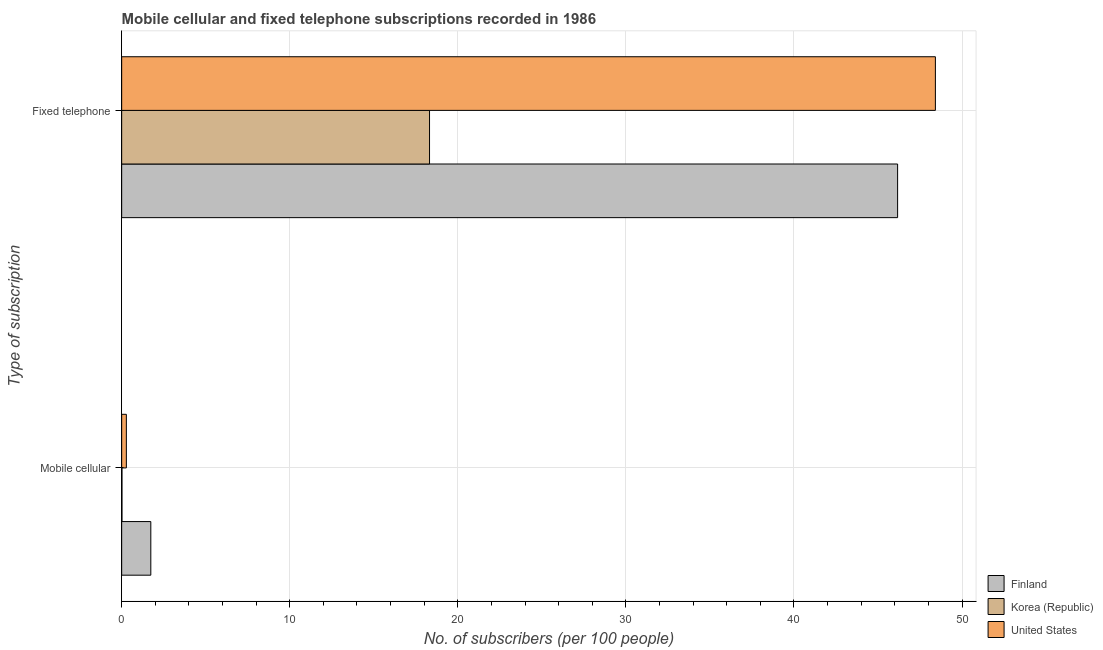How many different coloured bars are there?
Your response must be concise. 3. How many groups of bars are there?
Provide a short and direct response. 2. Are the number of bars per tick equal to the number of legend labels?
Offer a terse response. Yes. How many bars are there on the 1st tick from the top?
Give a very brief answer. 3. What is the label of the 2nd group of bars from the top?
Give a very brief answer. Mobile cellular. What is the number of mobile cellular subscribers in United States?
Your answer should be compact. 0.28. Across all countries, what is the maximum number of fixed telephone subscribers?
Make the answer very short. 48.41. Across all countries, what is the minimum number of fixed telephone subscribers?
Your answer should be compact. 18.32. In which country was the number of mobile cellular subscribers minimum?
Give a very brief answer. Korea (Republic). What is the total number of fixed telephone subscribers in the graph?
Your response must be concise. 112.9. What is the difference between the number of fixed telephone subscribers in Korea (Republic) and that in United States?
Ensure brevity in your answer.  -30.1. What is the difference between the number of fixed telephone subscribers in Korea (Republic) and the number of mobile cellular subscribers in Finland?
Make the answer very short. 16.58. What is the average number of fixed telephone subscribers per country?
Make the answer very short. 37.63. What is the difference between the number of mobile cellular subscribers and number of fixed telephone subscribers in Korea (Republic)?
Provide a short and direct response. -18.3. What is the ratio of the number of fixed telephone subscribers in United States to that in Korea (Republic)?
Your answer should be compact. 2.64. Is the number of mobile cellular subscribers in United States less than that in Finland?
Give a very brief answer. Yes. How many bars are there?
Offer a terse response. 6. Are all the bars in the graph horizontal?
Keep it short and to the point. Yes. How many countries are there in the graph?
Make the answer very short. 3. What is the difference between two consecutive major ticks on the X-axis?
Your answer should be very brief. 10. Are the values on the major ticks of X-axis written in scientific E-notation?
Your answer should be very brief. No. Does the graph contain grids?
Provide a succinct answer. Yes. How many legend labels are there?
Your answer should be very brief. 3. How are the legend labels stacked?
Offer a very short reply. Vertical. What is the title of the graph?
Offer a very short reply. Mobile cellular and fixed telephone subscriptions recorded in 1986. What is the label or title of the X-axis?
Provide a short and direct response. No. of subscribers (per 100 people). What is the label or title of the Y-axis?
Offer a terse response. Type of subscription. What is the No. of subscribers (per 100 people) in Finland in Mobile cellular?
Ensure brevity in your answer.  1.73. What is the No. of subscribers (per 100 people) in Korea (Republic) in Mobile cellular?
Your answer should be very brief. 0.02. What is the No. of subscribers (per 100 people) of United States in Mobile cellular?
Ensure brevity in your answer.  0.28. What is the No. of subscribers (per 100 people) in Finland in Fixed telephone?
Give a very brief answer. 46.17. What is the No. of subscribers (per 100 people) of Korea (Republic) in Fixed telephone?
Your answer should be compact. 18.32. What is the No. of subscribers (per 100 people) in United States in Fixed telephone?
Make the answer very short. 48.41. Across all Type of subscription, what is the maximum No. of subscribers (per 100 people) in Finland?
Your answer should be compact. 46.17. Across all Type of subscription, what is the maximum No. of subscribers (per 100 people) in Korea (Republic)?
Keep it short and to the point. 18.32. Across all Type of subscription, what is the maximum No. of subscribers (per 100 people) of United States?
Provide a short and direct response. 48.41. Across all Type of subscription, what is the minimum No. of subscribers (per 100 people) of Finland?
Provide a succinct answer. 1.73. Across all Type of subscription, what is the minimum No. of subscribers (per 100 people) of Korea (Republic)?
Offer a terse response. 0.02. Across all Type of subscription, what is the minimum No. of subscribers (per 100 people) of United States?
Your answer should be compact. 0.28. What is the total No. of subscribers (per 100 people) of Finland in the graph?
Provide a short and direct response. 47.9. What is the total No. of subscribers (per 100 people) of Korea (Republic) in the graph?
Ensure brevity in your answer.  18.33. What is the total No. of subscribers (per 100 people) in United States in the graph?
Offer a very short reply. 48.69. What is the difference between the No. of subscribers (per 100 people) in Finland in Mobile cellular and that in Fixed telephone?
Give a very brief answer. -44.43. What is the difference between the No. of subscribers (per 100 people) in Korea (Republic) in Mobile cellular and that in Fixed telephone?
Make the answer very short. -18.3. What is the difference between the No. of subscribers (per 100 people) of United States in Mobile cellular and that in Fixed telephone?
Make the answer very short. -48.13. What is the difference between the No. of subscribers (per 100 people) of Finland in Mobile cellular and the No. of subscribers (per 100 people) of Korea (Republic) in Fixed telephone?
Your answer should be compact. -16.58. What is the difference between the No. of subscribers (per 100 people) in Finland in Mobile cellular and the No. of subscribers (per 100 people) in United States in Fixed telephone?
Your answer should be very brief. -46.68. What is the difference between the No. of subscribers (per 100 people) in Korea (Republic) in Mobile cellular and the No. of subscribers (per 100 people) in United States in Fixed telephone?
Your answer should be very brief. -48.4. What is the average No. of subscribers (per 100 people) of Finland per Type of subscription?
Give a very brief answer. 23.95. What is the average No. of subscribers (per 100 people) in Korea (Republic) per Type of subscription?
Offer a very short reply. 9.17. What is the average No. of subscribers (per 100 people) in United States per Type of subscription?
Provide a short and direct response. 24.35. What is the difference between the No. of subscribers (per 100 people) in Finland and No. of subscribers (per 100 people) in Korea (Republic) in Mobile cellular?
Your response must be concise. 1.72. What is the difference between the No. of subscribers (per 100 people) in Finland and No. of subscribers (per 100 people) in United States in Mobile cellular?
Offer a terse response. 1.45. What is the difference between the No. of subscribers (per 100 people) in Korea (Republic) and No. of subscribers (per 100 people) in United States in Mobile cellular?
Provide a short and direct response. -0.26. What is the difference between the No. of subscribers (per 100 people) in Finland and No. of subscribers (per 100 people) in Korea (Republic) in Fixed telephone?
Offer a terse response. 27.85. What is the difference between the No. of subscribers (per 100 people) in Finland and No. of subscribers (per 100 people) in United States in Fixed telephone?
Your response must be concise. -2.25. What is the difference between the No. of subscribers (per 100 people) of Korea (Republic) and No. of subscribers (per 100 people) of United States in Fixed telephone?
Give a very brief answer. -30.1. What is the ratio of the No. of subscribers (per 100 people) in Finland in Mobile cellular to that in Fixed telephone?
Offer a terse response. 0.04. What is the ratio of the No. of subscribers (per 100 people) of Korea (Republic) in Mobile cellular to that in Fixed telephone?
Offer a terse response. 0. What is the ratio of the No. of subscribers (per 100 people) in United States in Mobile cellular to that in Fixed telephone?
Ensure brevity in your answer.  0.01. What is the difference between the highest and the second highest No. of subscribers (per 100 people) in Finland?
Ensure brevity in your answer.  44.43. What is the difference between the highest and the second highest No. of subscribers (per 100 people) of Korea (Republic)?
Provide a short and direct response. 18.3. What is the difference between the highest and the second highest No. of subscribers (per 100 people) in United States?
Make the answer very short. 48.13. What is the difference between the highest and the lowest No. of subscribers (per 100 people) in Finland?
Provide a short and direct response. 44.43. What is the difference between the highest and the lowest No. of subscribers (per 100 people) in Korea (Republic)?
Keep it short and to the point. 18.3. What is the difference between the highest and the lowest No. of subscribers (per 100 people) in United States?
Make the answer very short. 48.13. 